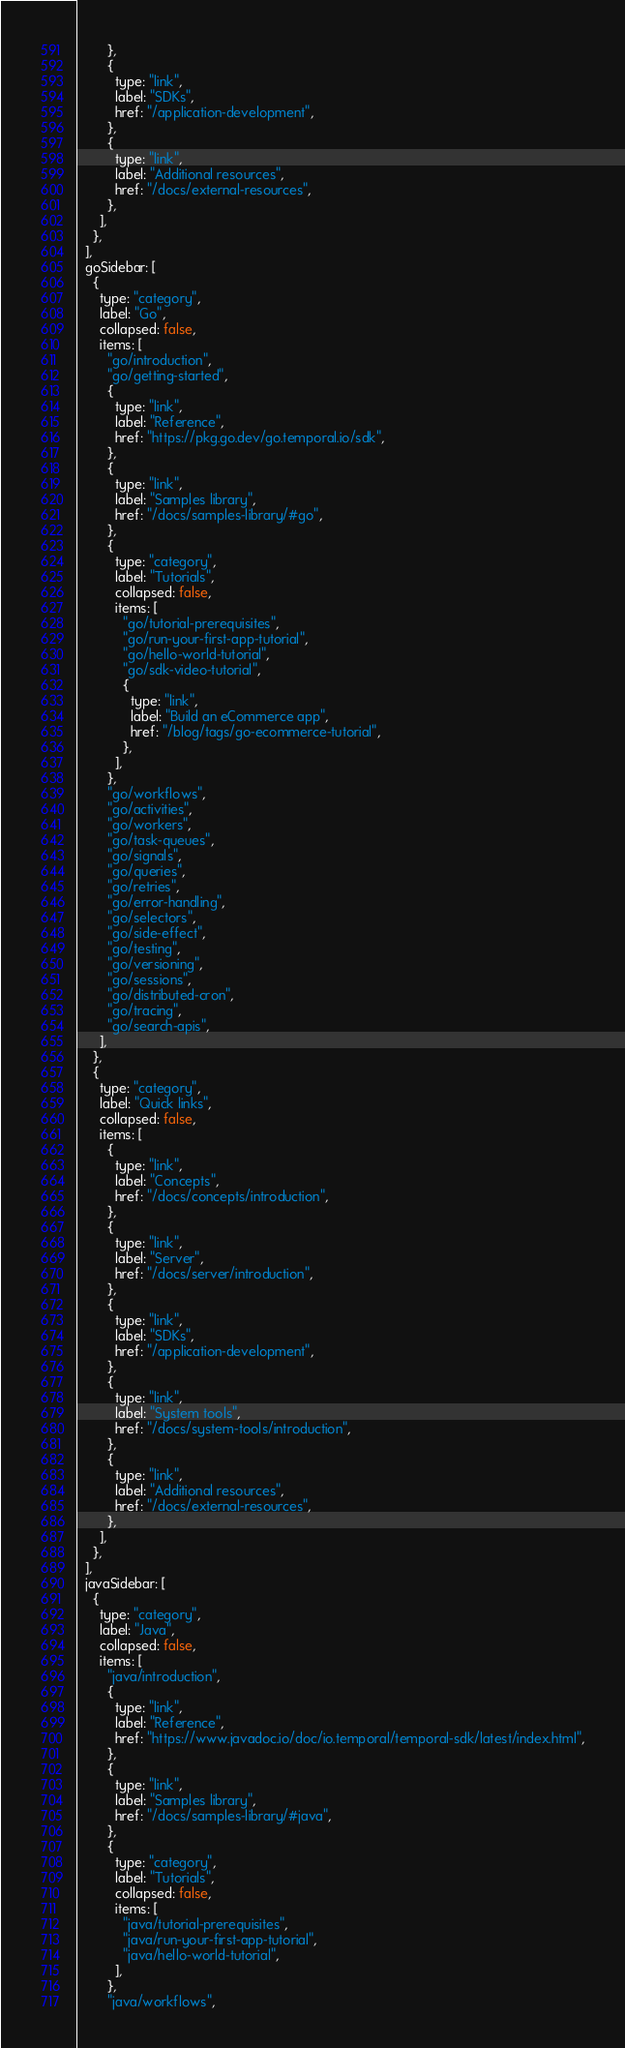Convert code to text. <code><loc_0><loc_0><loc_500><loc_500><_JavaScript_>        },
        {
          type: "link",
          label: "SDKs",
          href: "/application-development",
        },
        {
          type: "link",
          label: "Additional resources",
          href: "/docs/external-resources",
        },
      ],
    },
  ],
  goSidebar: [
    {
      type: "category",
      label: "Go",
      collapsed: false,
      items: [
        "go/introduction",
        "go/getting-started",
        {
          type: "link",
          label: "Reference",
          href: "https://pkg.go.dev/go.temporal.io/sdk",
        },
        {
          type: "link",
          label: "Samples library",
          href: "/docs/samples-library/#go",
        },
        {
          type: "category",
          label: "Tutorials",
          collapsed: false,
          items: [
            "go/tutorial-prerequisites",
            "go/run-your-first-app-tutorial",
            "go/hello-world-tutorial",
            "go/sdk-video-tutorial",
            {
              type: "link",
              label: "Build an eCommerce app",
              href: "/blog/tags/go-ecommerce-tutorial",
            },
          ],
        },
        "go/workflows",
        "go/activities",
        "go/workers",
        "go/task-queues",
        "go/signals",
        "go/queries",
        "go/retries",
        "go/error-handling",
        "go/selectors",
        "go/side-effect",
        "go/testing",
        "go/versioning",
        "go/sessions",
        "go/distributed-cron",
        "go/tracing",
        "go/search-apis",
      ],
    },
    {
      type: "category",
      label: "Quick links",
      collapsed: false,
      items: [
        {
          type: "link",
          label: "Concepts",
          href: "/docs/concepts/introduction",
        },
        {
          type: "link",
          label: "Server",
          href: "/docs/server/introduction",
        },
        {
          type: "link",
          label: "SDKs",
          href: "/application-development",
        },
        {
          type: "link",
          label: "System tools",
          href: "/docs/system-tools/introduction",
        },
        {
          type: "link",
          label: "Additional resources",
          href: "/docs/external-resources",
        },
      ],
    },
  ],
  javaSidebar: [
    {
      type: "category",
      label: "Java",
      collapsed: false,
      items: [
        "java/introduction",
        {
          type: "link",
          label: "Reference",
          href: "https://www.javadoc.io/doc/io.temporal/temporal-sdk/latest/index.html",
        },
        {
          type: "link",
          label: "Samples library",
          href: "/docs/samples-library/#java",
        },
        {
          type: "category",
          label: "Tutorials",
          collapsed: false,
          items: [
            "java/tutorial-prerequisites",
            "java/run-your-first-app-tutorial",
            "java/hello-world-tutorial",
          ],
        },
        "java/workflows",</code> 